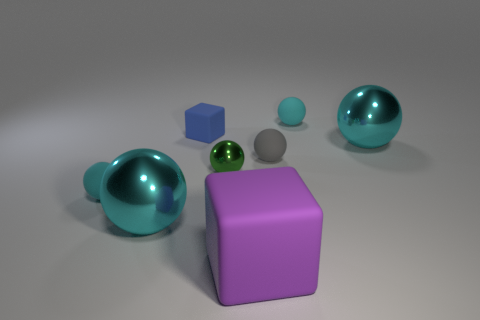Is there another tiny rubber object that has the same shape as the purple thing?
Your answer should be compact. Yes. The cube that is the same size as the gray sphere is what color?
Your response must be concise. Blue. There is a big metallic object left of the small ball right of the tiny gray matte object; what color is it?
Provide a succinct answer. Cyan. There is a big metal sphere left of the small gray sphere; is it the same color as the small metallic object?
Your answer should be compact. No. The cyan metal thing that is in front of the tiny cyan object to the left of the cyan metal object to the left of the green ball is what shape?
Offer a very short reply. Sphere. There is a small cyan sphere that is left of the large purple object; what number of gray objects are behind it?
Make the answer very short. 1. Is the small blue thing made of the same material as the big block?
Offer a very short reply. Yes. There is a small matte cube that is behind the big metallic ball behind the tiny gray ball; what number of shiny objects are on the right side of it?
Provide a short and direct response. 2. There is a metal object that is in front of the small green thing; what color is it?
Offer a terse response. Cyan. There is a big object on the right side of the cyan rubber sphere that is behind the tiny cube; what shape is it?
Provide a short and direct response. Sphere. 